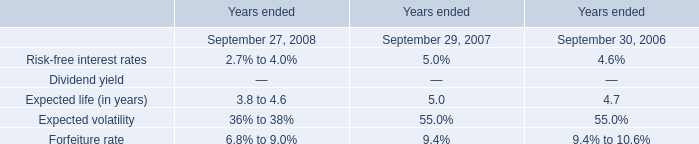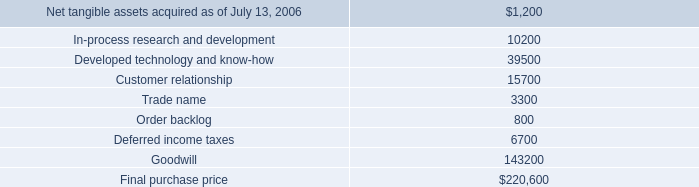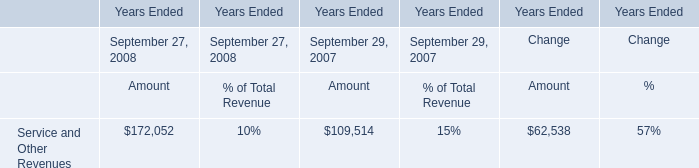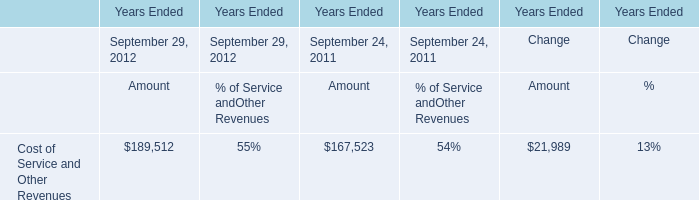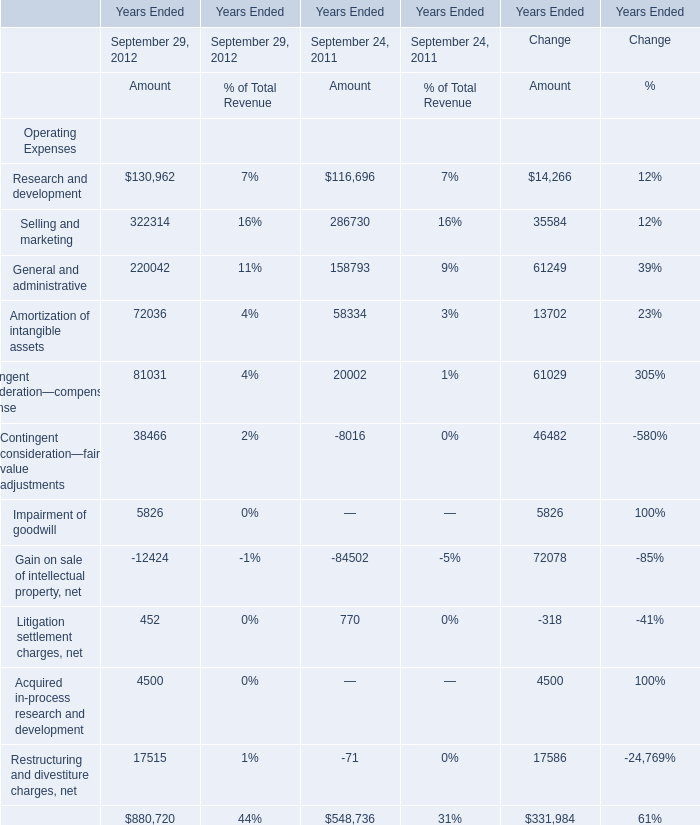what potion of the r2 acquisition is paid in cash? 
Computations: (6900 / 220600)
Answer: 0.03128. 